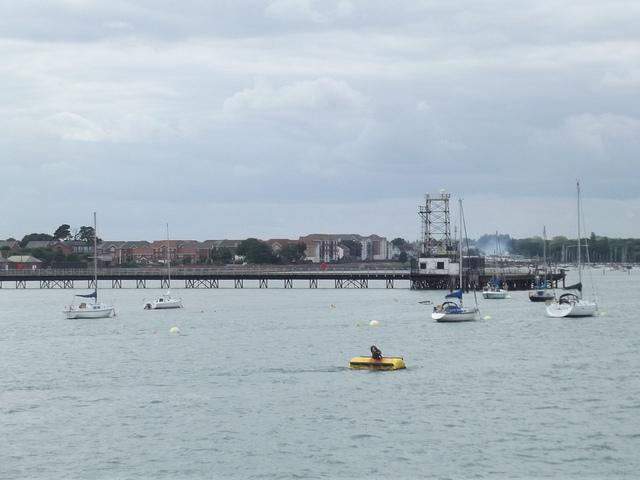What do many of the boats shown here normally use but lack here?

Choices:
A) pirates
B) sails
C) steam shovels
D) motors sails 